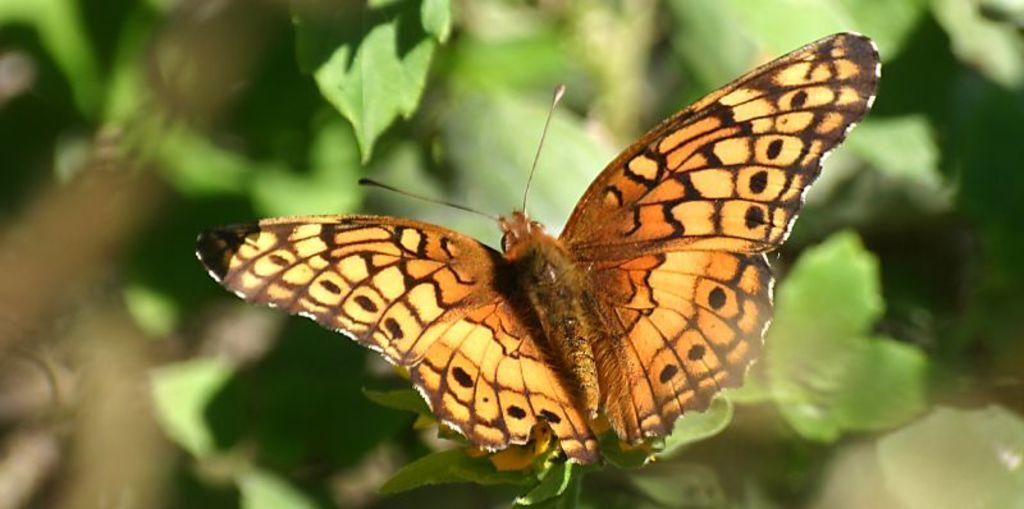What type of insect is present in the image? There is a butterfly in the image. What colors can be seen on the butterfly? The butterfly has orange, brown, and yellow colors. What type of vegetation is visible in the image? There are green leaves in the image. How would you describe the background of the image? The background is blurred. Who is delivering the parcel to the butterfly in the image? There is no parcel or delivery person present in the image; it features a butterfly with green leaves in the background. What type of surprise is the butterfly experiencing in the image? There is no indication of a surprise or any emotion in the image; it simply shows a butterfly with green leaves in the background. 